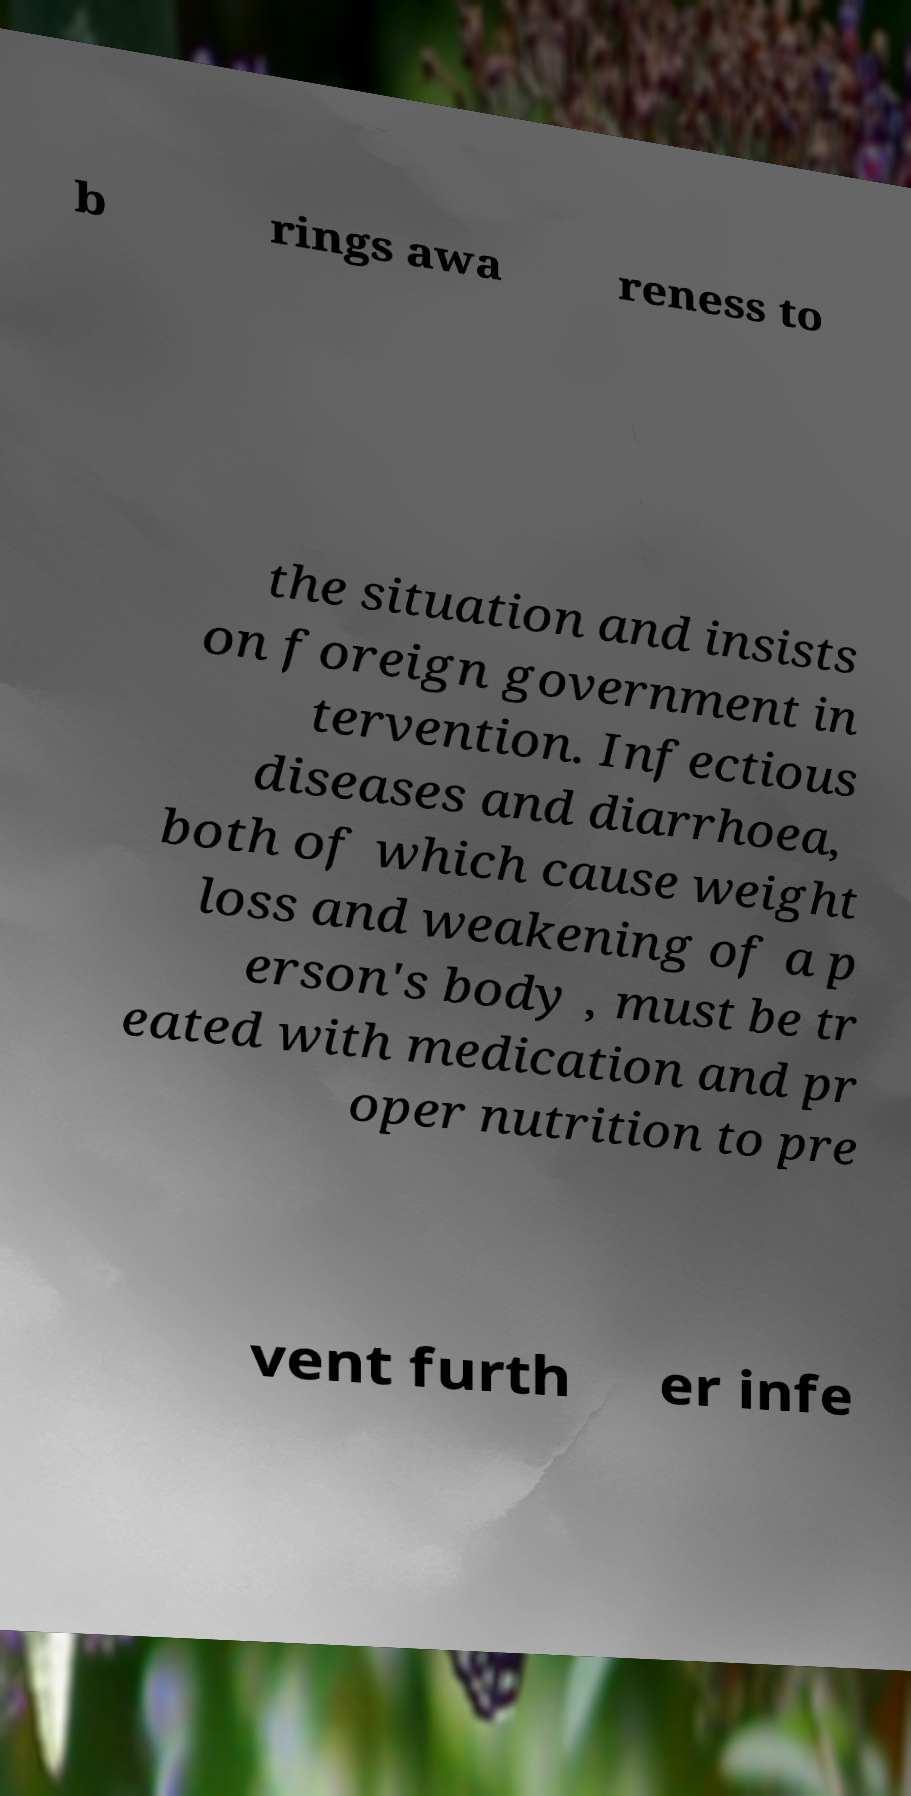For documentation purposes, I need the text within this image transcribed. Could you provide that? b rings awa reness to the situation and insists on foreign government in tervention. Infectious diseases and diarrhoea, both of which cause weight loss and weakening of a p erson's body , must be tr eated with medication and pr oper nutrition to pre vent furth er infe 